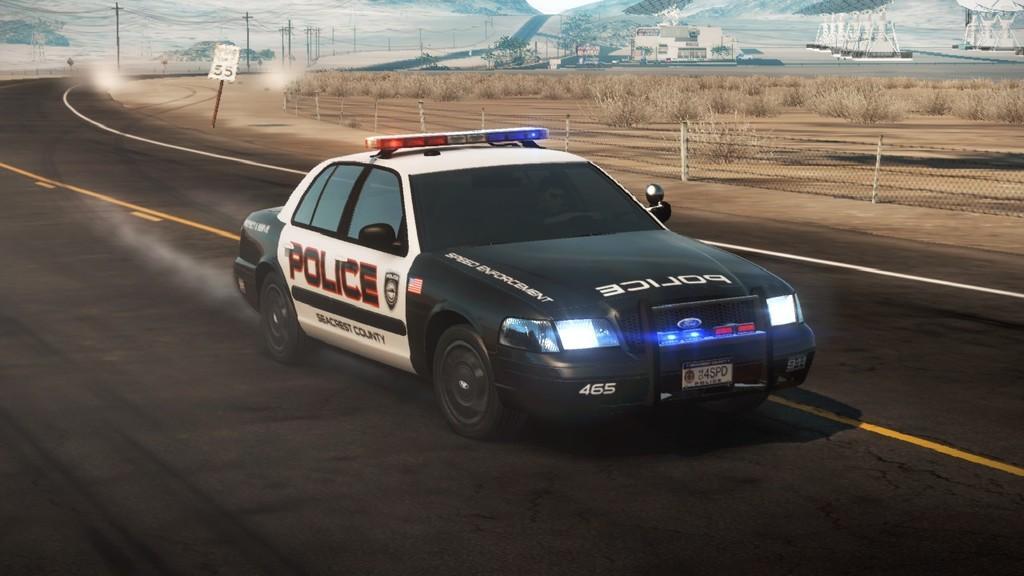How would you summarize this image in a sentence or two? In the image there is a police car on the road and around the car there is a fencing, dry plants, poles and in the background there are trees. 